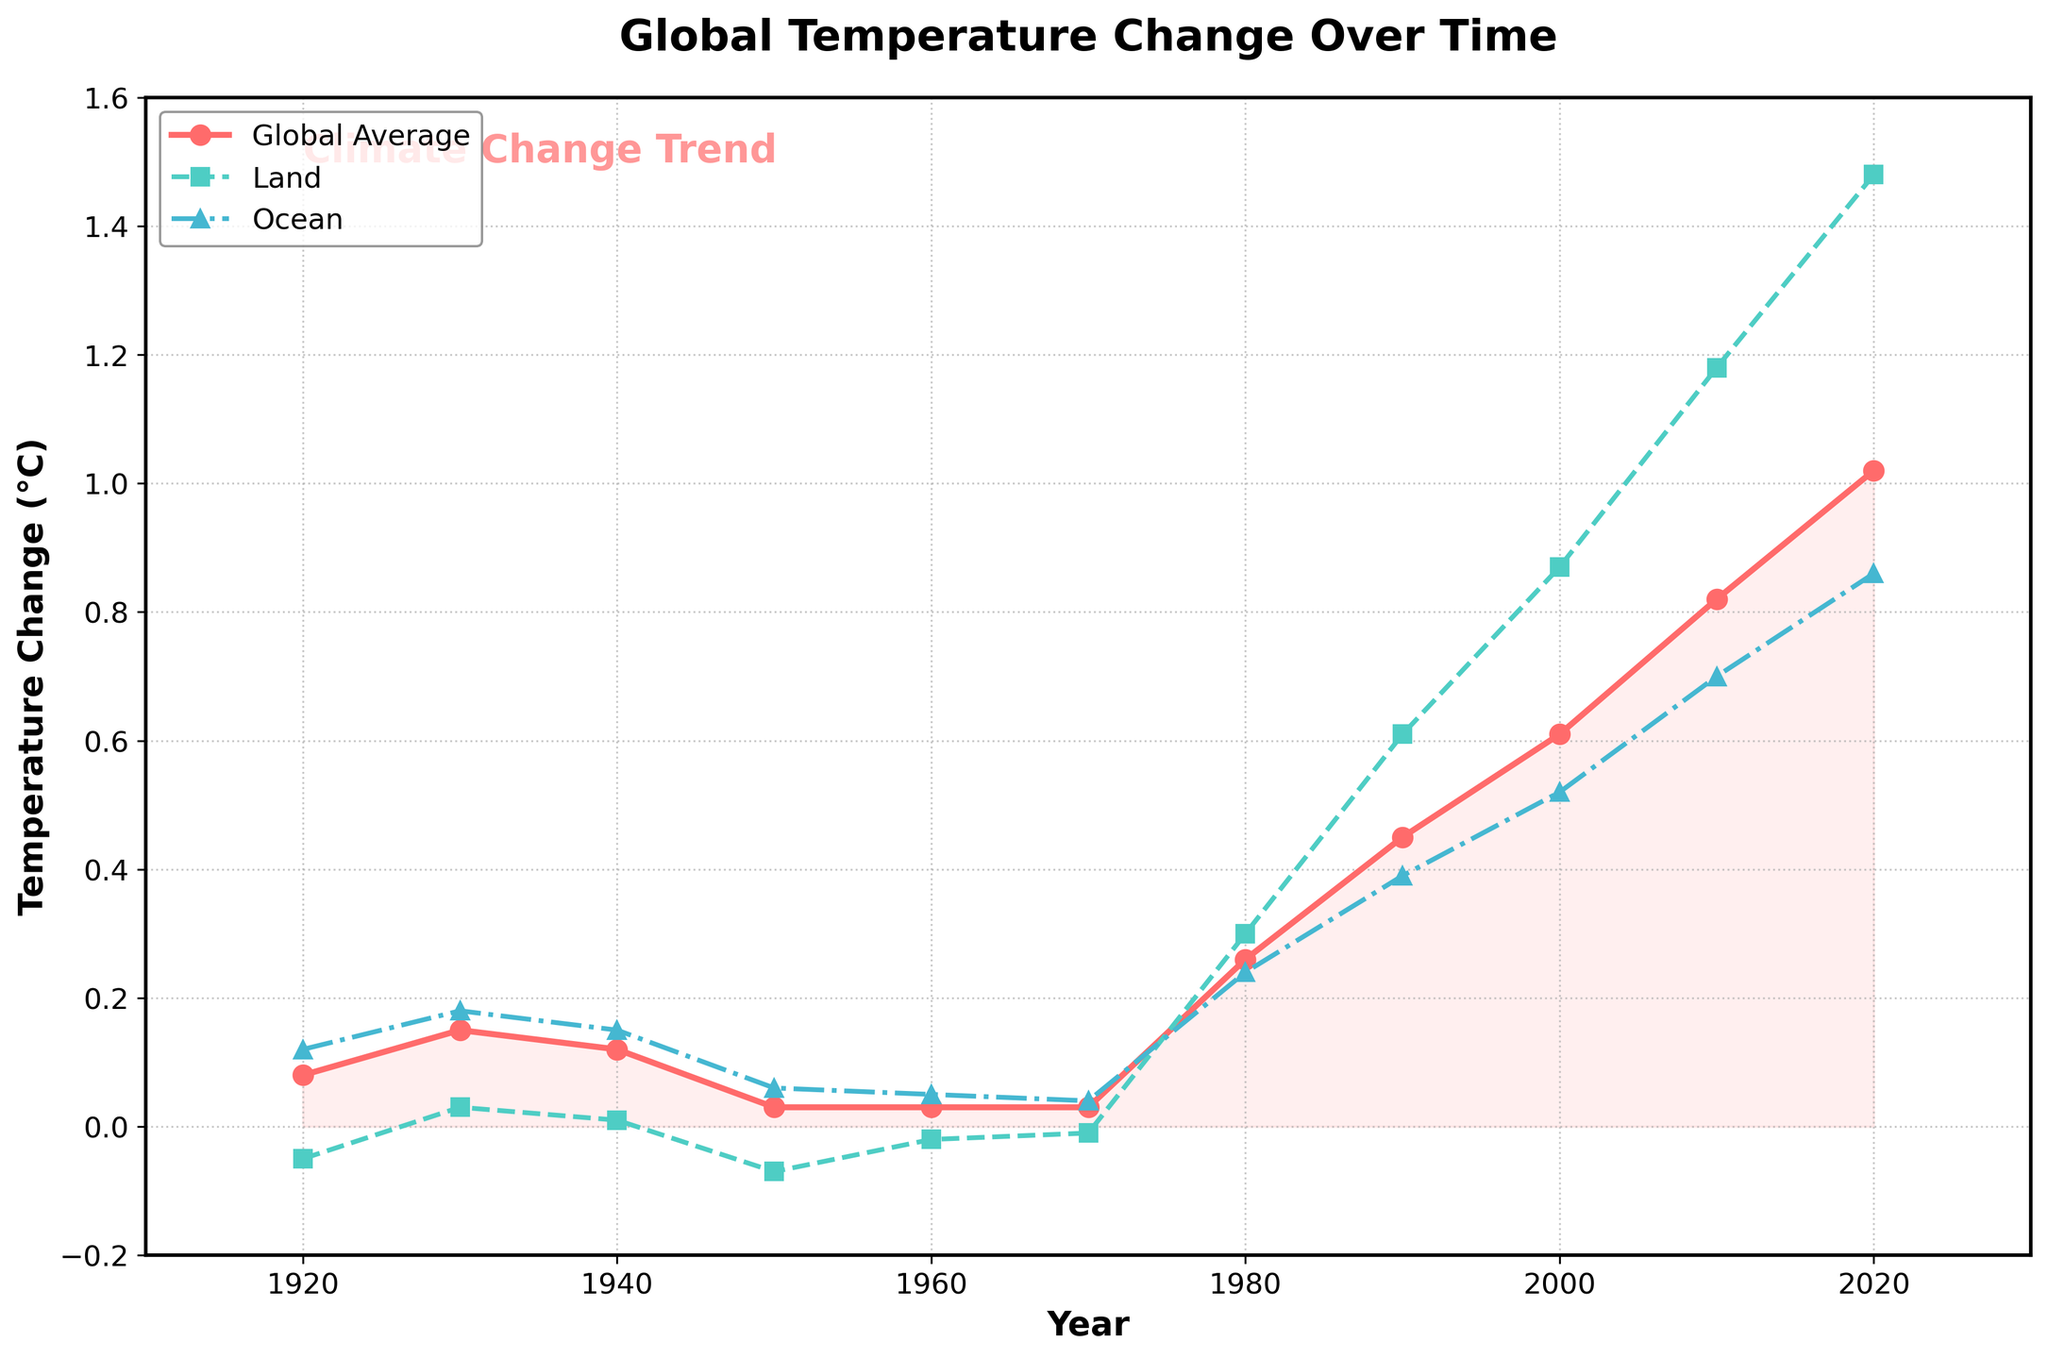What's the overall trend of the global average temperature change over the past century? The global average temperature change is shown to increase gradually over the years. The chart indicates a clear upward trend, especially from 1980 onwards, where the rate of increase becomes more pronounced. This demonstrates a long-term warming trend.
Answer: Increasing During which decade did the global land temperature change exceed 1°C for the first time? By examining the line representing the land temperature change, we see it first exceeds the 1°C mark in the 2010s. Specifically, around 2010 onward, the land temperature change surpasses 1°C.
Answer: 2010s Compare the land and ocean temperature changes in 2020. Which is higher and by how much? In 2020, land temperature change is approximately 1.48°C, whereas ocean temperature change is about 0.86°C. To find which is higher and by how much, subtract the ocean temperature change from the land temperature change: 1.48°C - 0.86°C = 0.62°C.
Answer: Land by 0.62°C Between which years did the global average temperature change increase the most? By reviewing the slope of the global average temperature line, the steepest increase appears between 2000 and 2010 and between 2010 and 2020. We calculate the difference between these intervals to confirm. From 2000 to 2010: 0.82°C - 0.61°C = 0.21°C, and from 2010 to 2020: 1.02°C - 0.82°C = 0.20°C. The interval 2000 to 2010 shows the greatest increase.
Answer: 2000 to 2010 What is the temperature change range for ocean temperatures throughout the century? The lowest ocean temperature change is around 0.04°C in 1970, and the highest is around 0.86°C in 2020. To find the range: 0.86°C - 0.04°C = 0.82°C.
Answer: 0.82°C How do the land and ocean temperature changes compare around the year 1980? Around 1980, the land temperature change is roughly 0.30°C, while the ocean temperature change is about 0.24°C. The land temperature change is higher than the ocean temperature change by 0.06°C.
Answer: Land is higher by 0.06°C What's the average global temperature change over the shown period? Sum all the global temperature changes and divide by the number of data points. (0.08 + 0.15 + 0.12 + 0.03 + 0.03 + 0.03 + 0.26 + 0.45 + 0.61 + 0.82 + 1.02) / 11 = 0.344°C.
Answer: 0.344°C What was the global temperature change in the year 1950, and how did it compare to the 1940 value? In 1950, the global temperature change was 0.03°C. In 1940, it was 0.12°C. Comparing these, the 1950 value is 0.09°C lower than the 1940 value.
Answer: 0.09°C lower 